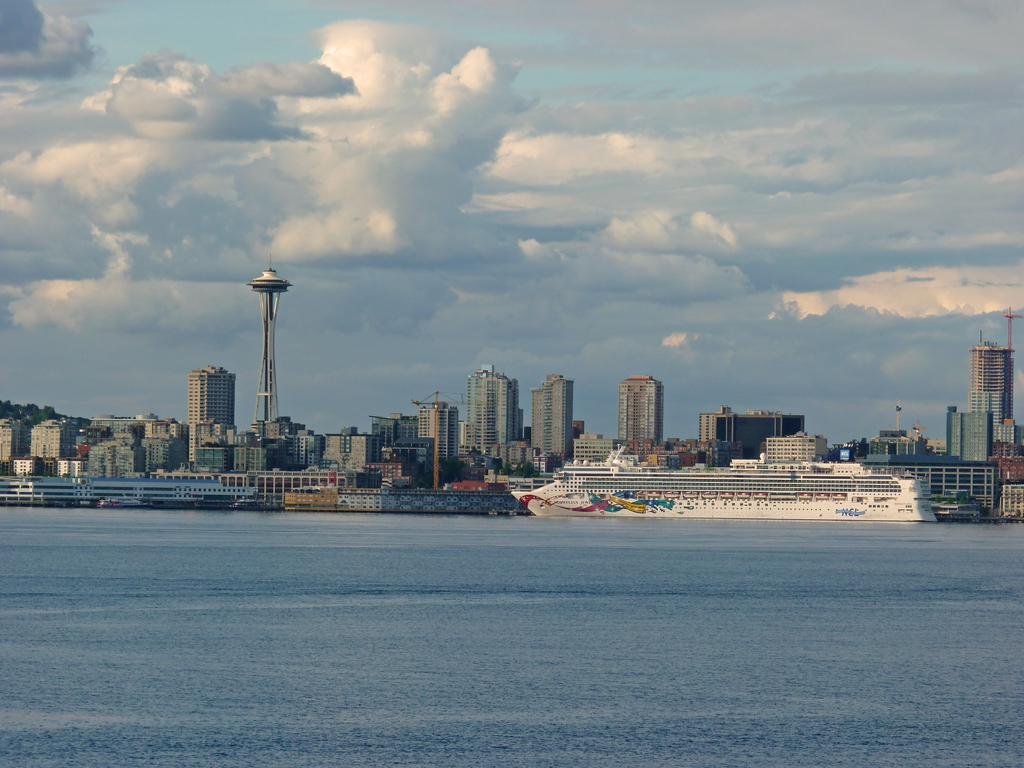How would you summarize this image in a sentence or two? In this picture there is a ship on the water. At the back there are buildings and there is a tower. At the top there is sky and there are clouds. At the bottom there is water. 